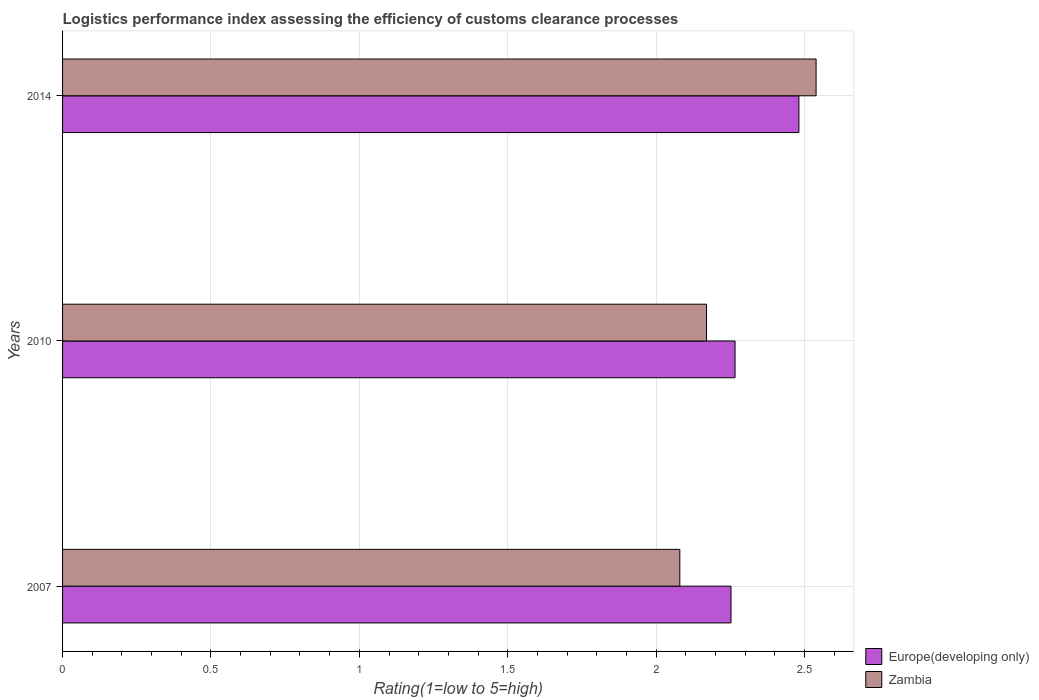How many different coloured bars are there?
Provide a succinct answer. 2. Are the number of bars per tick equal to the number of legend labels?
Make the answer very short. Yes. Are the number of bars on each tick of the Y-axis equal?
Offer a terse response. Yes. How many bars are there on the 3rd tick from the top?
Offer a terse response. 2. How many bars are there on the 2nd tick from the bottom?
Ensure brevity in your answer.  2. What is the Logistic performance index in Zambia in 2007?
Your answer should be very brief. 2.08. Across all years, what is the maximum Logistic performance index in Zambia?
Your answer should be very brief. 2.54. Across all years, what is the minimum Logistic performance index in Zambia?
Your response must be concise. 2.08. In which year was the Logistic performance index in Zambia minimum?
Offer a terse response. 2007. What is the total Logistic performance index in Europe(developing only) in the graph?
Offer a terse response. 7. What is the difference between the Logistic performance index in Europe(developing only) in 2007 and that in 2014?
Your answer should be very brief. -0.23. What is the difference between the Logistic performance index in Europe(developing only) in 2010 and the Logistic performance index in Zambia in 2007?
Ensure brevity in your answer.  0.19. What is the average Logistic performance index in Europe(developing only) per year?
Your answer should be compact. 2.33. In the year 2010, what is the difference between the Logistic performance index in Zambia and Logistic performance index in Europe(developing only)?
Ensure brevity in your answer.  -0.1. In how many years, is the Logistic performance index in Zambia greater than 0.8 ?
Make the answer very short. 3. What is the ratio of the Logistic performance index in Europe(developing only) in 2010 to that in 2014?
Give a very brief answer. 0.91. Is the difference between the Logistic performance index in Zambia in 2007 and 2014 greater than the difference between the Logistic performance index in Europe(developing only) in 2007 and 2014?
Offer a very short reply. No. What is the difference between the highest and the second highest Logistic performance index in Zambia?
Offer a terse response. 0.37. What is the difference between the highest and the lowest Logistic performance index in Europe(developing only)?
Make the answer very short. 0.23. In how many years, is the Logistic performance index in Europe(developing only) greater than the average Logistic performance index in Europe(developing only) taken over all years?
Provide a succinct answer. 1. What does the 1st bar from the top in 2014 represents?
Ensure brevity in your answer.  Zambia. What does the 2nd bar from the bottom in 2010 represents?
Offer a terse response. Zambia. How many bars are there?
Your response must be concise. 6. Are all the bars in the graph horizontal?
Your answer should be compact. Yes. Are the values on the major ticks of X-axis written in scientific E-notation?
Give a very brief answer. No. Does the graph contain any zero values?
Provide a succinct answer. No. Does the graph contain grids?
Keep it short and to the point. Yes. Where does the legend appear in the graph?
Ensure brevity in your answer.  Bottom right. How many legend labels are there?
Provide a short and direct response. 2. What is the title of the graph?
Your response must be concise. Logistics performance index assessing the efficiency of customs clearance processes. What is the label or title of the X-axis?
Give a very brief answer. Rating(1=low to 5=high). What is the label or title of the Y-axis?
Your response must be concise. Years. What is the Rating(1=low to 5=high) in Europe(developing only) in 2007?
Provide a succinct answer. 2.25. What is the Rating(1=low to 5=high) in Zambia in 2007?
Keep it short and to the point. 2.08. What is the Rating(1=low to 5=high) of Europe(developing only) in 2010?
Your response must be concise. 2.27. What is the Rating(1=low to 5=high) in Zambia in 2010?
Ensure brevity in your answer.  2.17. What is the Rating(1=low to 5=high) of Europe(developing only) in 2014?
Offer a very short reply. 2.48. What is the Rating(1=low to 5=high) of Zambia in 2014?
Ensure brevity in your answer.  2.54. Across all years, what is the maximum Rating(1=low to 5=high) of Europe(developing only)?
Offer a very short reply. 2.48. Across all years, what is the maximum Rating(1=low to 5=high) of Zambia?
Give a very brief answer. 2.54. Across all years, what is the minimum Rating(1=low to 5=high) in Europe(developing only)?
Give a very brief answer. 2.25. Across all years, what is the minimum Rating(1=low to 5=high) in Zambia?
Ensure brevity in your answer.  2.08. What is the total Rating(1=low to 5=high) of Europe(developing only) in the graph?
Offer a very short reply. 7. What is the total Rating(1=low to 5=high) in Zambia in the graph?
Offer a very short reply. 6.79. What is the difference between the Rating(1=low to 5=high) of Europe(developing only) in 2007 and that in 2010?
Provide a succinct answer. -0.01. What is the difference between the Rating(1=low to 5=high) in Zambia in 2007 and that in 2010?
Make the answer very short. -0.09. What is the difference between the Rating(1=low to 5=high) of Europe(developing only) in 2007 and that in 2014?
Keep it short and to the point. -0.23. What is the difference between the Rating(1=low to 5=high) of Zambia in 2007 and that in 2014?
Provide a succinct answer. -0.46. What is the difference between the Rating(1=low to 5=high) of Europe(developing only) in 2010 and that in 2014?
Offer a very short reply. -0.22. What is the difference between the Rating(1=low to 5=high) in Zambia in 2010 and that in 2014?
Keep it short and to the point. -0.37. What is the difference between the Rating(1=low to 5=high) of Europe(developing only) in 2007 and the Rating(1=low to 5=high) of Zambia in 2010?
Make the answer very short. 0.08. What is the difference between the Rating(1=low to 5=high) of Europe(developing only) in 2007 and the Rating(1=low to 5=high) of Zambia in 2014?
Make the answer very short. -0.29. What is the difference between the Rating(1=low to 5=high) in Europe(developing only) in 2010 and the Rating(1=low to 5=high) in Zambia in 2014?
Your answer should be very brief. -0.27. What is the average Rating(1=low to 5=high) of Europe(developing only) per year?
Provide a succinct answer. 2.33. What is the average Rating(1=low to 5=high) of Zambia per year?
Keep it short and to the point. 2.26. In the year 2007, what is the difference between the Rating(1=low to 5=high) in Europe(developing only) and Rating(1=low to 5=high) in Zambia?
Offer a very short reply. 0.17. In the year 2010, what is the difference between the Rating(1=low to 5=high) of Europe(developing only) and Rating(1=low to 5=high) of Zambia?
Offer a very short reply. 0.1. In the year 2014, what is the difference between the Rating(1=low to 5=high) of Europe(developing only) and Rating(1=low to 5=high) of Zambia?
Offer a very short reply. -0.06. What is the ratio of the Rating(1=low to 5=high) in Zambia in 2007 to that in 2010?
Keep it short and to the point. 0.96. What is the ratio of the Rating(1=low to 5=high) in Europe(developing only) in 2007 to that in 2014?
Provide a succinct answer. 0.91. What is the ratio of the Rating(1=low to 5=high) in Zambia in 2007 to that in 2014?
Provide a short and direct response. 0.82. What is the ratio of the Rating(1=low to 5=high) in Europe(developing only) in 2010 to that in 2014?
Offer a very short reply. 0.91. What is the ratio of the Rating(1=low to 5=high) of Zambia in 2010 to that in 2014?
Your answer should be very brief. 0.85. What is the difference between the highest and the second highest Rating(1=low to 5=high) of Europe(developing only)?
Your answer should be very brief. 0.22. What is the difference between the highest and the second highest Rating(1=low to 5=high) of Zambia?
Provide a short and direct response. 0.37. What is the difference between the highest and the lowest Rating(1=low to 5=high) in Europe(developing only)?
Your response must be concise. 0.23. What is the difference between the highest and the lowest Rating(1=low to 5=high) of Zambia?
Your answer should be compact. 0.46. 